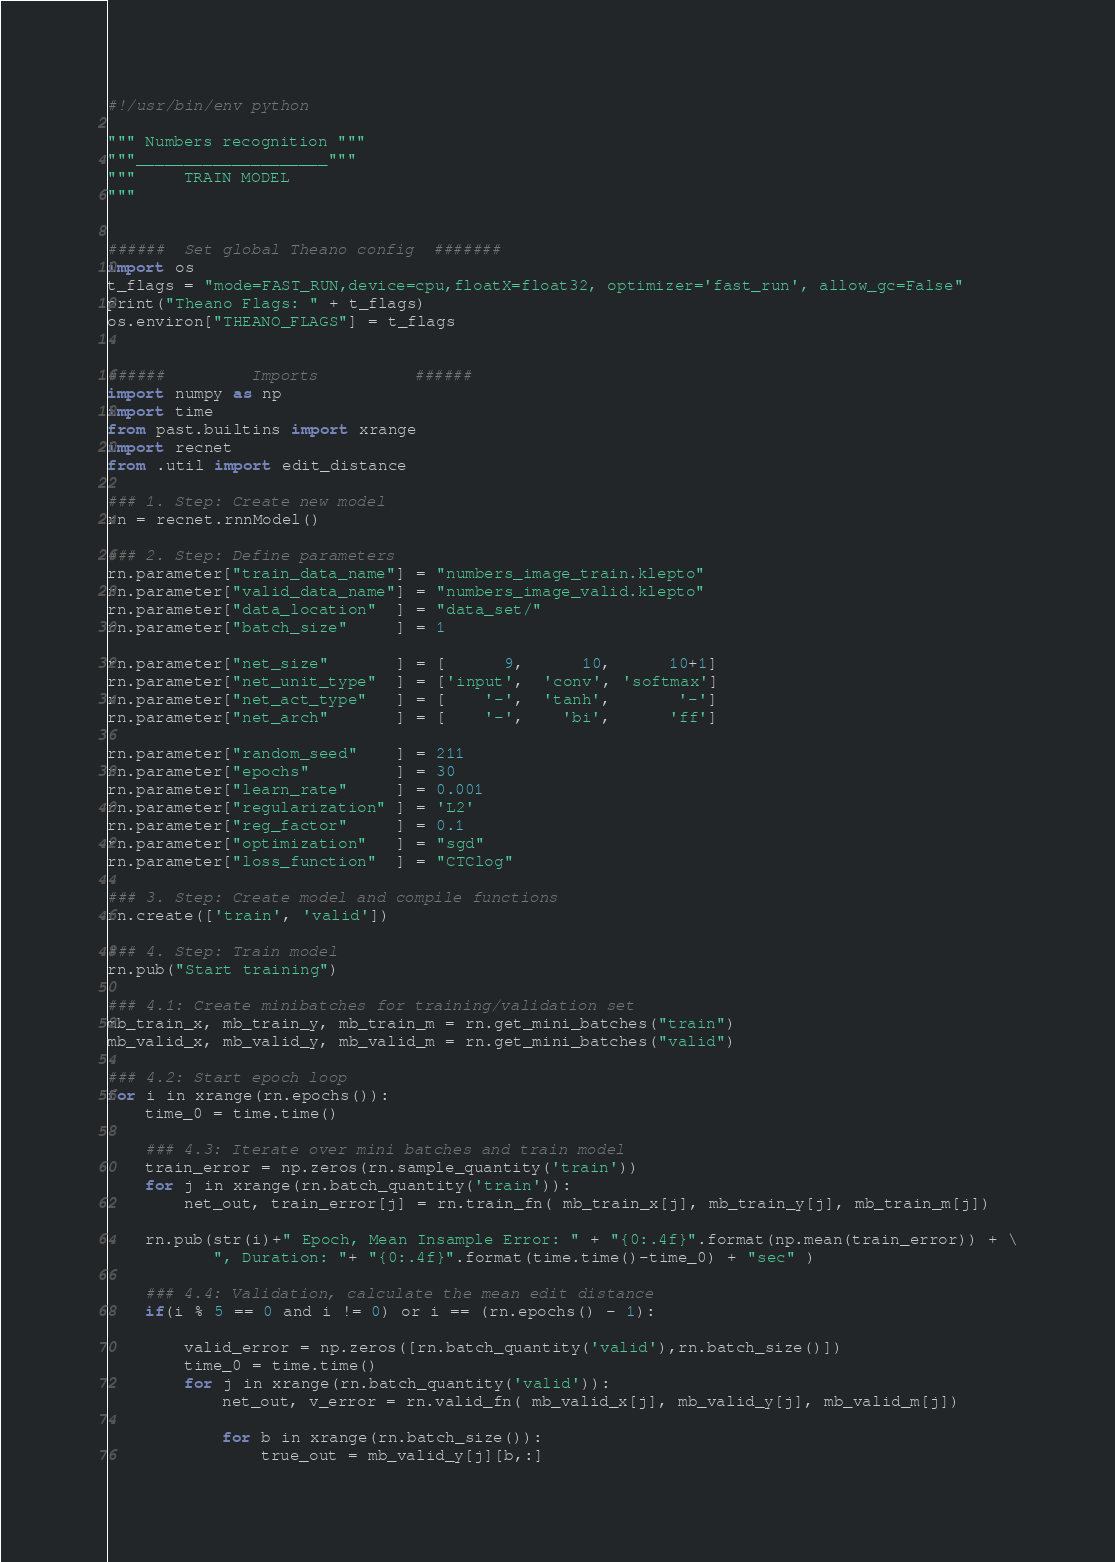<code> <loc_0><loc_0><loc_500><loc_500><_Python_>#!/usr/bin/env python

""" Numbers recognition """
"""____________________"""
"""     TRAIN MODEL
"""


######  Set global Theano config  #######
import os
t_flags = "mode=FAST_RUN,device=cpu,floatX=float32, optimizer='fast_run', allow_gc=False"
print("Theano Flags: " + t_flags)
os.environ["THEANO_FLAGS"] = t_flags


######         Imports          ######
import numpy as np
import time
from past.builtins import xrange
import recnet
from .util import edit_distance

### 1. Step: Create new model
rn = recnet.rnnModel()

### 2. Step: Define parameters
rn.parameter["train_data_name"] = "numbers_image_train.klepto"
rn.parameter["valid_data_name"] = "numbers_image_valid.klepto"
rn.parameter["data_location"  ] = "data_set/"
rn.parameter["batch_size"     ] = 1

rn.parameter["net_size"       ] = [      9,      10,      10+1]
rn.parameter["net_unit_type"  ] = ['input',  'conv', 'softmax']
rn.parameter["net_act_type"   ] = [    '-',  'tanh',       '-']
rn.parameter["net_arch"       ] = [    '-',    'bi',      'ff']

rn.parameter["random_seed"    ] = 211
rn.parameter["epochs"         ] = 30
rn.parameter["learn_rate"     ] = 0.001
rn.parameter["regularization" ] = 'L2'
rn.parameter["reg_factor"     ] = 0.1
rn.parameter["optimization"   ] = "sgd"
rn.parameter["loss_function"  ] = "CTClog"

### 3. Step: Create model and compile functions
rn.create(['train', 'valid'])

### 4. Step: Train model
rn.pub("Start training")

### 4.1: Create minibatches for training/validation set
mb_train_x, mb_train_y, mb_train_m = rn.get_mini_batches("train")
mb_valid_x, mb_valid_y, mb_valid_m = rn.get_mini_batches("valid")

### 4.2: Start epoch loop
for i in xrange(rn.epochs()):
    time_0 = time.time()

    ### 4.3: Iterate over mini batches and train model
    train_error = np.zeros(rn.sample_quantity('train'))
    for j in xrange(rn.batch_quantity('train')):
        net_out, train_error[j] = rn.train_fn( mb_train_x[j], mb_train_y[j], mb_train_m[j])

    rn.pub(str(i)+" Epoch, Mean Insample Error: " + "{0:.4f}".format(np.mean(train_error)) + \
           ", Duration: "+ "{0:.4f}".format(time.time()-time_0) + "sec" )

    ### 4.4: Validation, calculate the mean edit distance
    if(i % 5 == 0 and i != 0) or i == (rn.epochs() - 1):

        valid_error = np.zeros([rn.batch_quantity('valid'),rn.batch_size()])
        time_0 = time.time()
        for j in xrange(rn.batch_quantity('valid')):
            net_out, v_error = rn.valid_fn( mb_valid_x[j], mb_valid_y[j], mb_valid_m[j])

            for b in xrange(rn.batch_size()):
                true_out = mb_valid_y[j][b,:]</code> 